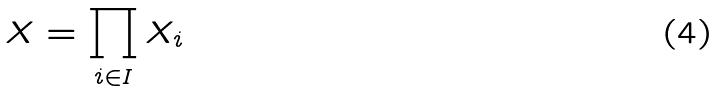<formula> <loc_0><loc_0><loc_500><loc_500>X = \prod _ { i \in I } X _ { i }</formula> 